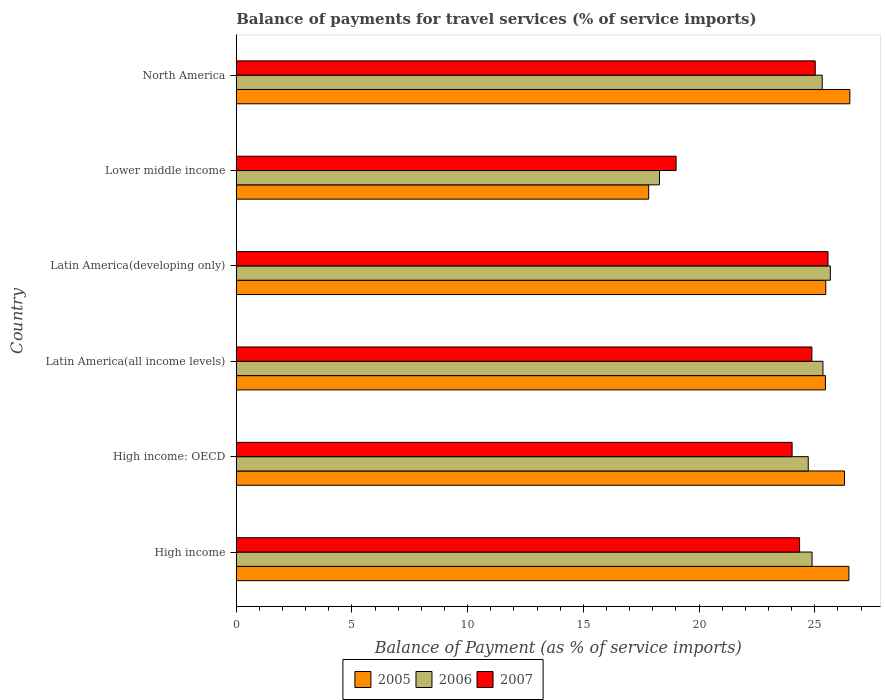How many groups of bars are there?
Ensure brevity in your answer.  6. Are the number of bars per tick equal to the number of legend labels?
Your response must be concise. Yes. How many bars are there on the 4th tick from the top?
Offer a terse response. 3. How many bars are there on the 4th tick from the bottom?
Provide a succinct answer. 3. What is the label of the 2nd group of bars from the top?
Provide a succinct answer. Lower middle income. In how many cases, is the number of bars for a given country not equal to the number of legend labels?
Provide a short and direct response. 0. What is the balance of payments for travel services in 2007 in High income: OECD?
Your answer should be compact. 24.02. Across all countries, what is the maximum balance of payments for travel services in 2006?
Keep it short and to the point. 25.68. Across all countries, what is the minimum balance of payments for travel services in 2005?
Provide a succinct answer. 17.82. In which country was the balance of payments for travel services in 2007 maximum?
Make the answer very short. Latin America(developing only). In which country was the balance of payments for travel services in 2006 minimum?
Provide a short and direct response. Lower middle income. What is the total balance of payments for travel services in 2006 in the graph?
Provide a short and direct response. 144.25. What is the difference between the balance of payments for travel services in 2006 in High income: OECD and that in Lower middle income?
Offer a very short reply. 6.43. What is the difference between the balance of payments for travel services in 2007 in Lower middle income and the balance of payments for travel services in 2005 in High income: OECD?
Give a very brief answer. -7.28. What is the average balance of payments for travel services in 2005 per country?
Keep it short and to the point. 24.67. What is the difference between the balance of payments for travel services in 2005 and balance of payments for travel services in 2006 in Lower middle income?
Provide a succinct answer. -0.47. In how many countries, is the balance of payments for travel services in 2006 greater than 1 %?
Offer a very short reply. 6. What is the ratio of the balance of payments for travel services in 2005 in Latin America(all income levels) to that in North America?
Keep it short and to the point. 0.96. Is the balance of payments for travel services in 2006 in High income: OECD less than that in Lower middle income?
Offer a terse response. No. What is the difference between the highest and the second highest balance of payments for travel services in 2006?
Offer a terse response. 0.32. What is the difference between the highest and the lowest balance of payments for travel services in 2007?
Ensure brevity in your answer.  6.56. In how many countries, is the balance of payments for travel services in 2007 greater than the average balance of payments for travel services in 2007 taken over all countries?
Provide a succinct answer. 5. Is the sum of the balance of payments for travel services in 2007 in Latin America(all income levels) and Lower middle income greater than the maximum balance of payments for travel services in 2006 across all countries?
Your answer should be very brief. Yes. What does the 1st bar from the bottom in North America represents?
Ensure brevity in your answer.  2005. How many bars are there?
Provide a short and direct response. 18. How many countries are there in the graph?
Give a very brief answer. 6. Are the values on the major ticks of X-axis written in scientific E-notation?
Your answer should be very brief. No. Does the graph contain any zero values?
Offer a terse response. No. Where does the legend appear in the graph?
Provide a short and direct response. Bottom center. How many legend labels are there?
Provide a short and direct response. 3. How are the legend labels stacked?
Offer a very short reply. Horizontal. What is the title of the graph?
Give a very brief answer. Balance of payments for travel services (% of service imports). What is the label or title of the X-axis?
Keep it short and to the point. Balance of Payment (as % of service imports). What is the label or title of the Y-axis?
Make the answer very short. Country. What is the Balance of Payment (as % of service imports) of 2005 in High income?
Keep it short and to the point. 26.48. What is the Balance of Payment (as % of service imports) of 2006 in High income?
Keep it short and to the point. 24.89. What is the Balance of Payment (as % of service imports) in 2007 in High income?
Provide a short and direct response. 24.34. What is the Balance of Payment (as % of service imports) of 2005 in High income: OECD?
Provide a succinct answer. 26.29. What is the Balance of Payment (as % of service imports) in 2006 in High income: OECD?
Your answer should be very brief. 24.72. What is the Balance of Payment (as % of service imports) of 2007 in High income: OECD?
Offer a terse response. 24.02. What is the Balance of Payment (as % of service imports) in 2005 in Latin America(all income levels)?
Give a very brief answer. 25.46. What is the Balance of Payment (as % of service imports) of 2006 in Latin America(all income levels)?
Provide a succinct answer. 25.36. What is the Balance of Payment (as % of service imports) in 2007 in Latin America(all income levels)?
Your response must be concise. 24.88. What is the Balance of Payment (as % of service imports) of 2005 in Latin America(developing only)?
Offer a very short reply. 25.48. What is the Balance of Payment (as % of service imports) in 2006 in Latin America(developing only)?
Provide a short and direct response. 25.68. What is the Balance of Payment (as % of service imports) in 2007 in Latin America(developing only)?
Make the answer very short. 25.57. What is the Balance of Payment (as % of service imports) in 2005 in Lower middle income?
Ensure brevity in your answer.  17.82. What is the Balance of Payment (as % of service imports) in 2006 in Lower middle income?
Make the answer very short. 18.29. What is the Balance of Payment (as % of service imports) in 2007 in Lower middle income?
Your answer should be very brief. 19.01. What is the Balance of Payment (as % of service imports) in 2005 in North America?
Provide a succinct answer. 26.52. What is the Balance of Payment (as % of service imports) of 2006 in North America?
Make the answer very short. 25.32. What is the Balance of Payment (as % of service imports) of 2007 in North America?
Your response must be concise. 25.02. Across all countries, what is the maximum Balance of Payment (as % of service imports) in 2005?
Provide a succinct answer. 26.52. Across all countries, what is the maximum Balance of Payment (as % of service imports) in 2006?
Offer a very short reply. 25.68. Across all countries, what is the maximum Balance of Payment (as % of service imports) of 2007?
Offer a terse response. 25.57. Across all countries, what is the minimum Balance of Payment (as % of service imports) of 2005?
Offer a very short reply. 17.82. Across all countries, what is the minimum Balance of Payment (as % of service imports) in 2006?
Offer a very short reply. 18.29. Across all countries, what is the minimum Balance of Payment (as % of service imports) of 2007?
Ensure brevity in your answer.  19.01. What is the total Balance of Payment (as % of service imports) of 2005 in the graph?
Provide a short and direct response. 148.04. What is the total Balance of Payment (as % of service imports) of 2006 in the graph?
Ensure brevity in your answer.  144.25. What is the total Balance of Payment (as % of service imports) in 2007 in the graph?
Provide a succinct answer. 142.85. What is the difference between the Balance of Payment (as % of service imports) of 2005 in High income and that in High income: OECD?
Ensure brevity in your answer.  0.19. What is the difference between the Balance of Payment (as % of service imports) in 2006 in High income and that in High income: OECD?
Keep it short and to the point. 0.17. What is the difference between the Balance of Payment (as % of service imports) in 2007 in High income and that in High income: OECD?
Your response must be concise. 0.32. What is the difference between the Balance of Payment (as % of service imports) in 2005 in High income and that in Latin America(all income levels)?
Provide a succinct answer. 1.01. What is the difference between the Balance of Payment (as % of service imports) of 2006 in High income and that in Latin America(all income levels)?
Your answer should be very brief. -0.47. What is the difference between the Balance of Payment (as % of service imports) of 2007 in High income and that in Latin America(all income levels)?
Your response must be concise. -0.53. What is the difference between the Balance of Payment (as % of service imports) of 2006 in High income and that in Latin America(developing only)?
Your response must be concise. -0.79. What is the difference between the Balance of Payment (as % of service imports) of 2007 in High income and that in Latin America(developing only)?
Provide a short and direct response. -1.23. What is the difference between the Balance of Payment (as % of service imports) of 2005 in High income and that in Lower middle income?
Provide a succinct answer. 8.65. What is the difference between the Balance of Payment (as % of service imports) in 2006 in High income and that in Lower middle income?
Provide a succinct answer. 6.59. What is the difference between the Balance of Payment (as % of service imports) of 2007 in High income and that in Lower middle income?
Provide a short and direct response. 5.34. What is the difference between the Balance of Payment (as % of service imports) of 2005 in High income and that in North America?
Your answer should be very brief. -0.04. What is the difference between the Balance of Payment (as % of service imports) of 2006 in High income and that in North America?
Give a very brief answer. -0.44. What is the difference between the Balance of Payment (as % of service imports) of 2007 in High income and that in North America?
Provide a succinct answer. -0.68. What is the difference between the Balance of Payment (as % of service imports) of 2005 in High income: OECD and that in Latin America(all income levels)?
Your answer should be compact. 0.82. What is the difference between the Balance of Payment (as % of service imports) of 2006 in High income: OECD and that in Latin America(all income levels)?
Make the answer very short. -0.64. What is the difference between the Balance of Payment (as % of service imports) of 2007 in High income: OECD and that in Latin America(all income levels)?
Make the answer very short. -0.85. What is the difference between the Balance of Payment (as % of service imports) in 2005 in High income: OECD and that in Latin America(developing only)?
Your answer should be compact. 0.81. What is the difference between the Balance of Payment (as % of service imports) of 2006 in High income: OECD and that in Latin America(developing only)?
Provide a short and direct response. -0.95. What is the difference between the Balance of Payment (as % of service imports) of 2007 in High income: OECD and that in Latin America(developing only)?
Your response must be concise. -1.55. What is the difference between the Balance of Payment (as % of service imports) in 2005 in High income: OECD and that in Lower middle income?
Your answer should be compact. 8.46. What is the difference between the Balance of Payment (as % of service imports) of 2006 in High income: OECD and that in Lower middle income?
Offer a very short reply. 6.43. What is the difference between the Balance of Payment (as % of service imports) in 2007 in High income: OECD and that in Lower middle income?
Offer a very short reply. 5.01. What is the difference between the Balance of Payment (as % of service imports) of 2005 in High income: OECD and that in North America?
Your answer should be compact. -0.23. What is the difference between the Balance of Payment (as % of service imports) of 2006 in High income: OECD and that in North America?
Offer a terse response. -0.6. What is the difference between the Balance of Payment (as % of service imports) in 2007 in High income: OECD and that in North America?
Keep it short and to the point. -1. What is the difference between the Balance of Payment (as % of service imports) of 2005 in Latin America(all income levels) and that in Latin America(developing only)?
Provide a short and direct response. -0.02. What is the difference between the Balance of Payment (as % of service imports) of 2006 in Latin America(all income levels) and that in Latin America(developing only)?
Offer a terse response. -0.32. What is the difference between the Balance of Payment (as % of service imports) of 2007 in Latin America(all income levels) and that in Latin America(developing only)?
Provide a succinct answer. -0.7. What is the difference between the Balance of Payment (as % of service imports) in 2005 in Latin America(all income levels) and that in Lower middle income?
Provide a short and direct response. 7.64. What is the difference between the Balance of Payment (as % of service imports) of 2006 in Latin America(all income levels) and that in Lower middle income?
Make the answer very short. 7.06. What is the difference between the Balance of Payment (as % of service imports) in 2007 in Latin America(all income levels) and that in Lower middle income?
Offer a terse response. 5.87. What is the difference between the Balance of Payment (as % of service imports) of 2005 in Latin America(all income levels) and that in North America?
Your response must be concise. -1.05. What is the difference between the Balance of Payment (as % of service imports) in 2006 in Latin America(all income levels) and that in North America?
Provide a short and direct response. 0.03. What is the difference between the Balance of Payment (as % of service imports) of 2007 in Latin America(all income levels) and that in North America?
Provide a short and direct response. -0.14. What is the difference between the Balance of Payment (as % of service imports) of 2005 in Latin America(developing only) and that in Lower middle income?
Your response must be concise. 7.65. What is the difference between the Balance of Payment (as % of service imports) of 2006 in Latin America(developing only) and that in Lower middle income?
Provide a short and direct response. 7.38. What is the difference between the Balance of Payment (as % of service imports) in 2007 in Latin America(developing only) and that in Lower middle income?
Make the answer very short. 6.56. What is the difference between the Balance of Payment (as % of service imports) of 2005 in Latin America(developing only) and that in North America?
Offer a very short reply. -1.04. What is the difference between the Balance of Payment (as % of service imports) in 2006 in Latin America(developing only) and that in North America?
Offer a very short reply. 0.35. What is the difference between the Balance of Payment (as % of service imports) of 2007 in Latin America(developing only) and that in North America?
Give a very brief answer. 0.55. What is the difference between the Balance of Payment (as % of service imports) of 2005 in Lower middle income and that in North America?
Give a very brief answer. -8.69. What is the difference between the Balance of Payment (as % of service imports) in 2006 in Lower middle income and that in North America?
Offer a very short reply. -7.03. What is the difference between the Balance of Payment (as % of service imports) of 2007 in Lower middle income and that in North America?
Make the answer very short. -6.01. What is the difference between the Balance of Payment (as % of service imports) in 2005 in High income and the Balance of Payment (as % of service imports) in 2006 in High income: OECD?
Provide a short and direct response. 1.76. What is the difference between the Balance of Payment (as % of service imports) in 2005 in High income and the Balance of Payment (as % of service imports) in 2007 in High income: OECD?
Offer a very short reply. 2.45. What is the difference between the Balance of Payment (as % of service imports) of 2006 in High income and the Balance of Payment (as % of service imports) of 2007 in High income: OECD?
Ensure brevity in your answer.  0.86. What is the difference between the Balance of Payment (as % of service imports) of 2005 in High income and the Balance of Payment (as % of service imports) of 2006 in Latin America(all income levels)?
Keep it short and to the point. 1.12. What is the difference between the Balance of Payment (as % of service imports) in 2005 in High income and the Balance of Payment (as % of service imports) in 2007 in Latin America(all income levels)?
Make the answer very short. 1.6. What is the difference between the Balance of Payment (as % of service imports) of 2006 in High income and the Balance of Payment (as % of service imports) of 2007 in Latin America(all income levels)?
Provide a succinct answer. 0.01. What is the difference between the Balance of Payment (as % of service imports) of 2005 in High income and the Balance of Payment (as % of service imports) of 2006 in Latin America(developing only)?
Offer a very short reply. 0.8. What is the difference between the Balance of Payment (as % of service imports) of 2005 in High income and the Balance of Payment (as % of service imports) of 2007 in Latin America(developing only)?
Provide a short and direct response. 0.9. What is the difference between the Balance of Payment (as % of service imports) of 2006 in High income and the Balance of Payment (as % of service imports) of 2007 in Latin America(developing only)?
Your answer should be compact. -0.69. What is the difference between the Balance of Payment (as % of service imports) of 2005 in High income and the Balance of Payment (as % of service imports) of 2006 in Lower middle income?
Your answer should be very brief. 8.19. What is the difference between the Balance of Payment (as % of service imports) of 2005 in High income and the Balance of Payment (as % of service imports) of 2007 in Lower middle income?
Your response must be concise. 7.47. What is the difference between the Balance of Payment (as % of service imports) in 2006 in High income and the Balance of Payment (as % of service imports) in 2007 in Lower middle income?
Your response must be concise. 5.88. What is the difference between the Balance of Payment (as % of service imports) in 2005 in High income and the Balance of Payment (as % of service imports) in 2006 in North America?
Offer a very short reply. 1.15. What is the difference between the Balance of Payment (as % of service imports) of 2005 in High income and the Balance of Payment (as % of service imports) of 2007 in North America?
Your answer should be compact. 1.46. What is the difference between the Balance of Payment (as % of service imports) of 2006 in High income and the Balance of Payment (as % of service imports) of 2007 in North America?
Your answer should be very brief. -0.14. What is the difference between the Balance of Payment (as % of service imports) of 2005 in High income: OECD and the Balance of Payment (as % of service imports) of 2006 in Latin America(all income levels)?
Ensure brevity in your answer.  0.93. What is the difference between the Balance of Payment (as % of service imports) in 2005 in High income: OECD and the Balance of Payment (as % of service imports) in 2007 in Latin America(all income levels)?
Ensure brevity in your answer.  1.41. What is the difference between the Balance of Payment (as % of service imports) of 2006 in High income: OECD and the Balance of Payment (as % of service imports) of 2007 in Latin America(all income levels)?
Keep it short and to the point. -0.16. What is the difference between the Balance of Payment (as % of service imports) in 2005 in High income: OECD and the Balance of Payment (as % of service imports) in 2006 in Latin America(developing only)?
Give a very brief answer. 0.61. What is the difference between the Balance of Payment (as % of service imports) of 2005 in High income: OECD and the Balance of Payment (as % of service imports) of 2007 in Latin America(developing only)?
Provide a short and direct response. 0.71. What is the difference between the Balance of Payment (as % of service imports) of 2006 in High income: OECD and the Balance of Payment (as % of service imports) of 2007 in Latin America(developing only)?
Provide a short and direct response. -0.85. What is the difference between the Balance of Payment (as % of service imports) of 2005 in High income: OECD and the Balance of Payment (as % of service imports) of 2006 in Lower middle income?
Keep it short and to the point. 8. What is the difference between the Balance of Payment (as % of service imports) of 2005 in High income: OECD and the Balance of Payment (as % of service imports) of 2007 in Lower middle income?
Give a very brief answer. 7.28. What is the difference between the Balance of Payment (as % of service imports) of 2006 in High income: OECD and the Balance of Payment (as % of service imports) of 2007 in Lower middle income?
Provide a short and direct response. 5.71. What is the difference between the Balance of Payment (as % of service imports) in 2005 in High income: OECD and the Balance of Payment (as % of service imports) in 2006 in North America?
Give a very brief answer. 0.96. What is the difference between the Balance of Payment (as % of service imports) in 2005 in High income: OECD and the Balance of Payment (as % of service imports) in 2007 in North America?
Offer a terse response. 1.27. What is the difference between the Balance of Payment (as % of service imports) of 2006 in High income: OECD and the Balance of Payment (as % of service imports) of 2007 in North America?
Keep it short and to the point. -0.3. What is the difference between the Balance of Payment (as % of service imports) in 2005 in Latin America(all income levels) and the Balance of Payment (as % of service imports) in 2006 in Latin America(developing only)?
Provide a succinct answer. -0.21. What is the difference between the Balance of Payment (as % of service imports) in 2005 in Latin America(all income levels) and the Balance of Payment (as % of service imports) in 2007 in Latin America(developing only)?
Your answer should be compact. -0.11. What is the difference between the Balance of Payment (as % of service imports) in 2006 in Latin America(all income levels) and the Balance of Payment (as % of service imports) in 2007 in Latin America(developing only)?
Offer a very short reply. -0.22. What is the difference between the Balance of Payment (as % of service imports) of 2005 in Latin America(all income levels) and the Balance of Payment (as % of service imports) of 2006 in Lower middle income?
Offer a terse response. 7.17. What is the difference between the Balance of Payment (as % of service imports) of 2005 in Latin America(all income levels) and the Balance of Payment (as % of service imports) of 2007 in Lower middle income?
Offer a very short reply. 6.45. What is the difference between the Balance of Payment (as % of service imports) of 2006 in Latin America(all income levels) and the Balance of Payment (as % of service imports) of 2007 in Lower middle income?
Your answer should be compact. 6.35. What is the difference between the Balance of Payment (as % of service imports) of 2005 in Latin America(all income levels) and the Balance of Payment (as % of service imports) of 2006 in North America?
Ensure brevity in your answer.  0.14. What is the difference between the Balance of Payment (as % of service imports) in 2005 in Latin America(all income levels) and the Balance of Payment (as % of service imports) in 2007 in North America?
Give a very brief answer. 0.44. What is the difference between the Balance of Payment (as % of service imports) in 2006 in Latin America(all income levels) and the Balance of Payment (as % of service imports) in 2007 in North America?
Offer a very short reply. 0.33. What is the difference between the Balance of Payment (as % of service imports) of 2005 in Latin America(developing only) and the Balance of Payment (as % of service imports) of 2006 in Lower middle income?
Keep it short and to the point. 7.19. What is the difference between the Balance of Payment (as % of service imports) of 2005 in Latin America(developing only) and the Balance of Payment (as % of service imports) of 2007 in Lower middle income?
Provide a succinct answer. 6.47. What is the difference between the Balance of Payment (as % of service imports) of 2006 in Latin America(developing only) and the Balance of Payment (as % of service imports) of 2007 in Lower middle income?
Your response must be concise. 6.67. What is the difference between the Balance of Payment (as % of service imports) in 2005 in Latin America(developing only) and the Balance of Payment (as % of service imports) in 2006 in North America?
Keep it short and to the point. 0.15. What is the difference between the Balance of Payment (as % of service imports) of 2005 in Latin America(developing only) and the Balance of Payment (as % of service imports) of 2007 in North America?
Provide a succinct answer. 0.46. What is the difference between the Balance of Payment (as % of service imports) in 2006 in Latin America(developing only) and the Balance of Payment (as % of service imports) in 2007 in North America?
Ensure brevity in your answer.  0.65. What is the difference between the Balance of Payment (as % of service imports) in 2005 in Lower middle income and the Balance of Payment (as % of service imports) in 2006 in North America?
Your answer should be very brief. -7.5. What is the difference between the Balance of Payment (as % of service imports) of 2005 in Lower middle income and the Balance of Payment (as % of service imports) of 2007 in North America?
Keep it short and to the point. -7.2. What is the difference between the Balance of Payment (as % of service imports) of 2006 in Lower middle income and the Balance of Payment (as % of service imports) of 2007 in North America?
Your response must be concise. -6.73. What is the average Balance of Payment (as % of service imports) in 2005 per country?
Your answer should be very brief. 24.67. What is the average Balance of Payment (as % of service imports) of 2006 per country?
Keep it short and to the point. 24.04. What is the average Balance of Payment (as % of service imports) of 2007 per country?
Your answer should be compact. 23.81. What is the difference between the Balance of Payment (as % of service imports) of 2005 and Balance of Payment (as % of service imports) of 2006 in High income?
Ensure brevity in your answer.  1.59. What is the difference between the Balance of Payment (as % of service imports) of 2005 and Balance of Payment (as % of service imports) of 2007 in High income?
Keep it short and to the point. 2.13. What is the difference between the Balance of Payment (as % of service imports) of 2006 and Balance of Payment (as % of service imports) of 2007 in High income?
Your answer should be very brief. 0.54. What is the difference between the Balance of Payment (as % of service imports) in 2005 and Balance of Payment (as % of service imports) in 2006 in High income: OECD?
Offer a very short reply. 1.57. What is the difference between the Balance of Payment (as % of service imports) of 2005 and Balance of Payment (as % of service imports) of 2007 in High income: OECD?
Provide a succinct answer. 2.26. What is the difference between the Balance of Payment (as % of service imports) in 2006 and Balance of Payment (as % of service imports) in 2007 in High income: OECD?
Your answer should be compact. 0.7. What is the difference between the Balance of Payment (as % of service imports) of 2005 and Balance of Payment (as % of service imports) of 2006 in Latin America(all income levels)?
Provide a succinct answer. 0.11. What is the difference between the Balance of Payment (as % of service imports) in 2005 and Balance of Payment (as % of service imports) in 2007 in Latin America(all income levels)?
Your answer should be very brief. 0.59. What is the difference between the Balance of Payment (as % of service imports) in 2006 and Balance of Payment (as % of service imports) in 2007 in Latin America(all income levels)?
Give a very brief answer. 0.48. What is the difference between the Balance of Payment (as % of service imports) of 2005 and Balance of Payment (as % of service imports) of 2006 in Latin America(developing only)?
Offer a terse response. -0.2. What is the difference between the Balance of Payment (as % of service imports) of 2005 and Balance of Payment (as % of service imports) of 2007 in Latin America(developing only)?
Keep it short and to the point. -0.1. What is the difference between the Balance of Payment (as % of service imports) of 2006 and Balance of Payment (as % of service imports) of 2007 in Latin America(developing only)?
Ensure brevity in your answer.  0.1. What is the difference between the Balance of Payment (as % of service imports) of 2005 and Balance of Payment (as % of service imports) of 2006 in Lower middle income?
Your answer should be very brief. -0.47. What is the difference between the Balance of Payment (as % of service imports) in 2005 and Balance of Payment (as % of service imports) in 2007 in Lower middle income?
Make the answer very short. -1.19. What is the difference between the Balance of Payment (as % of service imports) in 2006 and Balance of Payment (as % of service imports) in 2007 in Lower middle income?
Provide a succinct answer. -0.72. What is the difference between the Balance of Payment (as % of service imports) in 2005 and Balance of Payment (as % of service imports) in 2006 in North America?
Make the answer very short. 1.19. What is the difference between the Balance of Payment (as % of service imports) of 2005 and Balance of Payment (as % of service imports) of 2007 in North America?
Provide a succinct answer. 1.49. What is the difference between the Balance of Payment (as % of service imports) in 2006 and Balance of Payment (as % of service imports) in 2007 in North America?
Make the answer very short. 0.3. What is the ratio of the Balance of Payment (as % of service imports) in 2005 in High income to that in High income: OECD?
Offer a terse response. 1.01. What is the ratio of the Balance of Payment (as % of service imports) in 2007 in High income to that in High income: OECD?
Offer a terse response. 1.01. What is the ratio of the Balance of Payment (as % of service imports) in 2005 in High income to that in Latin America(all income levels)?
Offer a terse response. 1.04. What is the ratio of the Balance of Payment (as % of service imports) in 2006 in High income to that in Latin America(all income levels)?
Your answer should be compact. 0.98. What is the ratio of the Balance of Payment (as % of service imports) in 2007 in High income to that in Latin America(all income levels)?
Make the answer very short. 0.98. What is the ratio of the Balance of Payment (as % of service imports) of 2005 in High income to that in Latin America(developing only)?
Keep it short and to the point. 1.04. What is the ratio of the Balance of Payment (as % of service imports) of 2006 in High income to that in Latin America(developing only)?
Provide a short and direct response. 0.97. What is the ratio of the Balance of Payment (as % of service imports) in 2007 in High income to that in Latin America(developing only)?
Your response must be concise. 0.95. What is the ratio of the Balance of Payment (as % of service imports) of 2005 in High income to that in Lower middle income?
Your answer should be compact. 1.49. What is the ratio of the Balance of Payment (as % of service imports) of 2006 in High income to that in Lower middle income?
Your answer should be very brief. 1.36. What is the ratio of the Balance of Payment (as % of service imports) of 2007 in High income to that in Lower middle income?
Make the answer very short. 1.28. What is the ratio of the Balance of Payment (as % of service imports) of 2005 in High income to that in North America?
Give a very brief answer. 1. What is the ratio of the Balance of Payment (as % of service imports) of 2006 in High income to that in North America?
Provide a short and direct response. 0.98. What is the ratio of the Balance of Payment (as % of service imports) in 2007 in High income to that in North America?
Provide a succinct answer. 0.97. What is the ratio of the Balance of Payment (as % of service imports) of 2005 in High income: OECD to that in Latin America(all income levels)?
Offer a terse response. 1.03. What is the ratio of the Balance of Payment (as % of service imports) of 2007 in High income: OECD to that in Latin America(all income levels)?
Provide a succinct answer. 0.97. What is the ratio of the Balance of Payment (as % of service imports) in 2005 in High income: OECD to that in Latin America(developing only)?
Offer a very short reply. 1.03. What is the ratio of the Balance of Payment (as % of service imports) of 2006 in High income: OECD to that in Latin America(developing only)?
Keep it short and to the point. 0.96. What is the ratio of the Balance of Payment (as % of service imports) of 2007 in High income: OECD to that in Latin America(developing only)?
Give a very brief answer. 0.94. What is the ratio of the Balance of Payment (as % of service imports) in 2005 in High income: OECD to that in Lower middle income?
Provide a short and direct response. 1.47. What is the ratio of the Balance of Payment (as % of service imports) of 2006 in High income: OECD to that in Lower middle income?
Keep it short and to the point. 1.35. What is the ratio of the Balance of Payment (as % of service imports) of 2007 in High income: OECD to that in Lower middle income?
Provide a short and direct response. 1.26. What is the ratio of the Balance of Payment (as % of service imports) in 2005 in High income: OECD to that in North America?
Give a very brief answer. 0.99. What is the ratio of the Balance of Payment (as % of service imports) of 2006 in High income: OECD to that in North America?
Keep it short and to the point. 0.98. What is the ratio of the Balance of Payment (as % of service imports) in 2007 in High income: OECD to that in North America?
Your answer should be compact. 0.96. What is the ratio of the Balance of Payment (as % of service imports) of 2006 in Latin America(all income levels) to that in Latin America(developing only)?
Offer a terse response. 0.99. What is the ratio of the Balance of Payment (as % of service imports) of 2007 in Latin America(all income levels) to that in Latin America(developing only)?
Ensure brevity in your answer.  0.97. What is the ratio of the Balance of Payment (as % of service imports) of 2005 in Latin America(all income levels) to that in Lower middle income?
Your response must be concise. 1.43. What is the ratio of the Balance of Payment (as % of service imports) in 2006 in Latin America(all income levels) to that in Lower middle income?
Your answer should be very brief. 1.39. What is the ratio of the Balance of Payment (as % of service imports) of 2007 in Latin America(all income levels) to that in Lower middle income?
Your answer should be compact. 1.31. What is the ratio of the Balance of Payment (as % of service imports) in 2005 in Latin America(all income levels) to that in North America?
Your response must be concise. 0.96. What is the ratio of the Balance of Payment (as % of service imports) of 2006 in Latin America(all income levels) to that in North America?
Provide a succinct answer. 1. What is the ratio of the Balance of Payment (as % of service imports) in 2005 in Latin America(developing only) to that in Lower middle income?
Provide a short and direct response. 1.43. What is the ratio of the Balance of Payment (as % of service imports) of 2006 in Latin America(developing only) to that in Lower middle income?
Provide a short and direct response. 1.4. What is the ratio of the Balance of Payment (as % of service imports) in 2007 in Latin America(developing only) to that in Lower middle income?
Your answer should be very brief. 1.35. What is the ratio of the Balance of Payment (as % of service imports) in 2005 in Latin America(developing only) to that in North America?
Your response must be concise. 0.96. What is the ratio of the Balance of Payment (as % of service imports) in 2006 in Latin America(developing only) to that in North America?
Your response must be concise. 1.01. What is the ratio of the Balance of Payment (as % of service imports) of 2007 in Latin America(developing only) to that in North America?
Make the answer very short. 1.02. What is the ratio of the Balance of Payment (as % of service imports) of 2005 in Lower middle income to that in North America?
Provide a succinct answer. 0.67. What is the ratio of the Balance of Payment (as % of service imports) in 2006 in Lower middle income to that in North America?
Make the answer very short. 0.72. What is the ratio of the Balance of Payment (as % of service imports) in 2007 in Lower middle income to that in North America?
Give a very brief answer. 0.76. What is the difference between the highest and the second highest Balance of Payment (as % of service imports) in 2005?
Make the answer very short. 0.04. What is the difference between the highest and the second highest Balance of Payment (as % of service imports) in 2006?
Your answer should be very brief. 0.32. What is the difference between the highest and the second highest Balance of Payment (as % of service imports) in 2007?
Your answer should be very brief. 0.55. What is the difference between the highest and the lowest Balance of Payment (as % of service imports) of 2005?
Your answer should be very brief. 8.69. What is the difference between the highest and the lowest Balance of Payment (as % of service imports) in 2006?
Ensure brevity in your answer.  7.38. What is the difference between the highest and the lowest Balance of Payment (as % of service imports) of 2007?
Give a very brief answer. 6.56. 